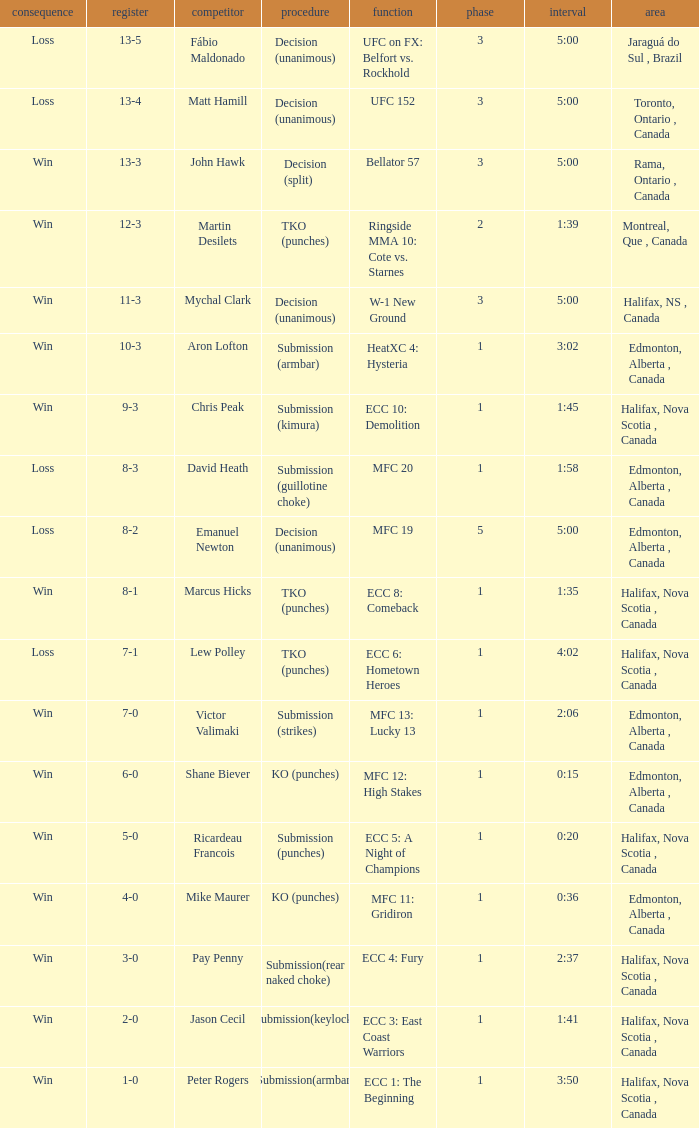What is the method of the match with 1 round and a time of 1:58? Submission (guillotine choke). 